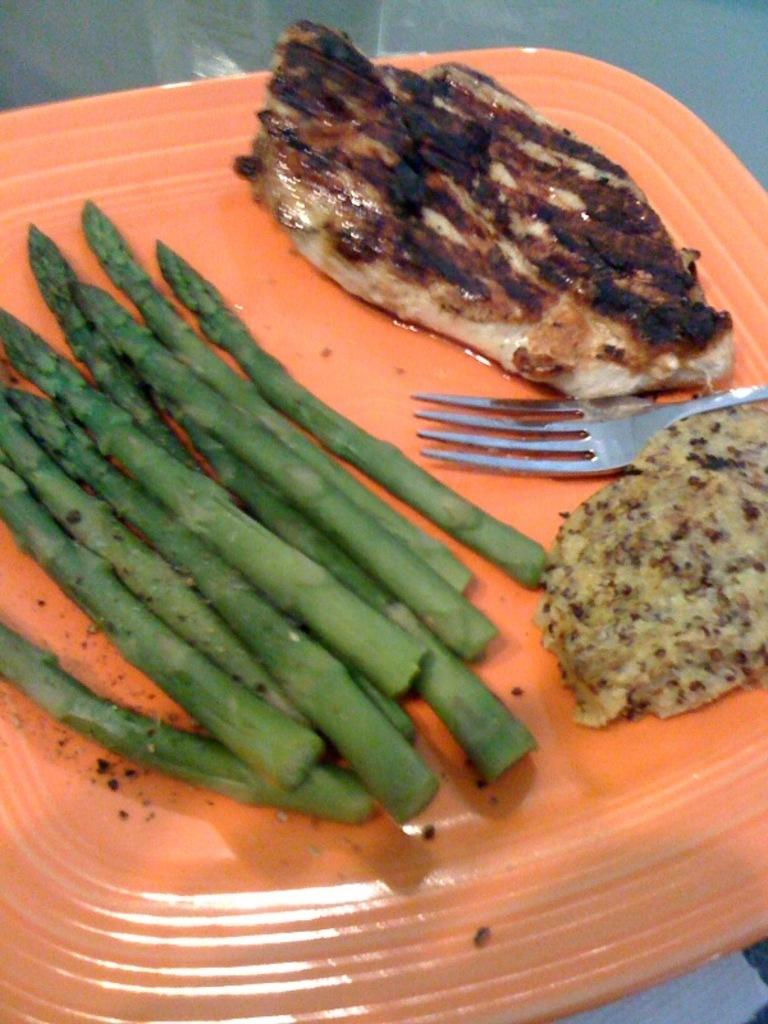What type of objects are present in the image? There are food items in the image. What is the color of the plate on which the food items are placed? The plate is orange in color. What utensil can be seen in the image? There is a fork in the image. How many flowers are present on the plate? There are no flowers present on the plate; the image features food items on an orange plate. 